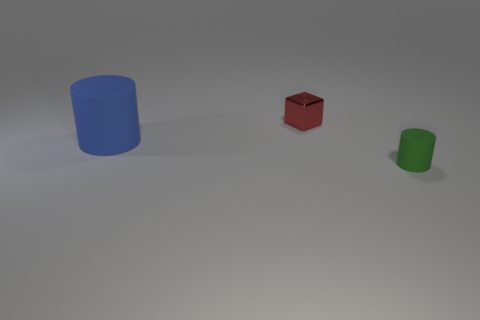How many metallic things are either blue cubes or big objects?
Provide a short and direct response. 0. What is the material of the small thing that is in front of the rubber thing that is to the left of the shiny object?
Ensure brevity in your answer.  Rubber. How many objects are either brown metallic cubes or objects that are on the right side of the tiny red shiny object?
Ensure brevity in your answer.  1. There is a green thing that is made of the same material as the large blue cylinder; what size is it?
Give a very brief answer. Small. What number of blue things are either small cubes or matte objects?
Make the answer very short. 1. Is there any other thing that is made of the same material as the tiny block?
Ensure brevity in your answer.  No. Does the rubber object that is right of the large blue cylinder have the same shape as the rubber object that is left of the red block?
Give a very brief answer. Yes. How many green things are there?
Provide a short and direct response. 1. Is there any other thing that is the same color as the metal thing?
Provide a short and direct response. No. Is the number of big blue matte cylinders that are in front of the small matte thing less than the number of large purple metallic blocks?
Provide a succinct answer. No. 